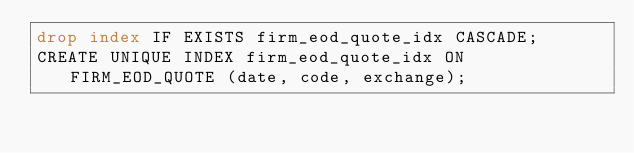Convert code to text. <code><loc_0><loc_0><loc_500><loc_500><_SQL_>drop index IF EXISTS firm_eod_quote_idx CASCADE;
CREATE UNIQUE INDEX firm_eod_quote_idx ON FIRM_EOD_QUOTE (date, code, exchange);


</code> 